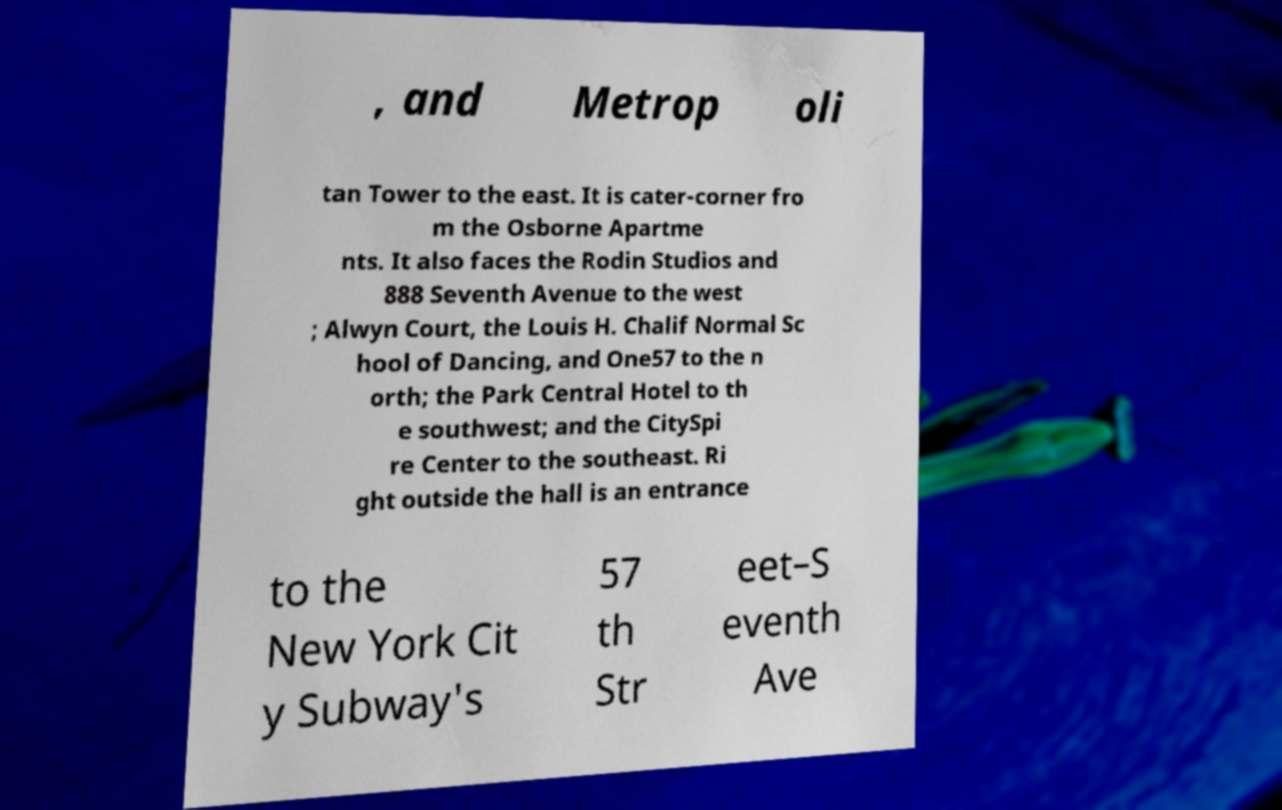Could you assist in decoding the text presented in this image and type it out clearly? , and Metrop oli tan Tower to the east. It is cater-corner fro m the Osborne Apartme nts. It also faces the Rodin Studios and 888 Seventh Avenue to the west ; Alwyn Court, the Louis H. Chalif Normal Sc hool of Dancing, and One57 to the n orth; the Park Central Hotel to th e southwest; and the CitySpi re Center to the southeast. Ri ght outside the hall is an entrance to the New York Cit y Subway's 57 th Str eet–S eventh Ave 